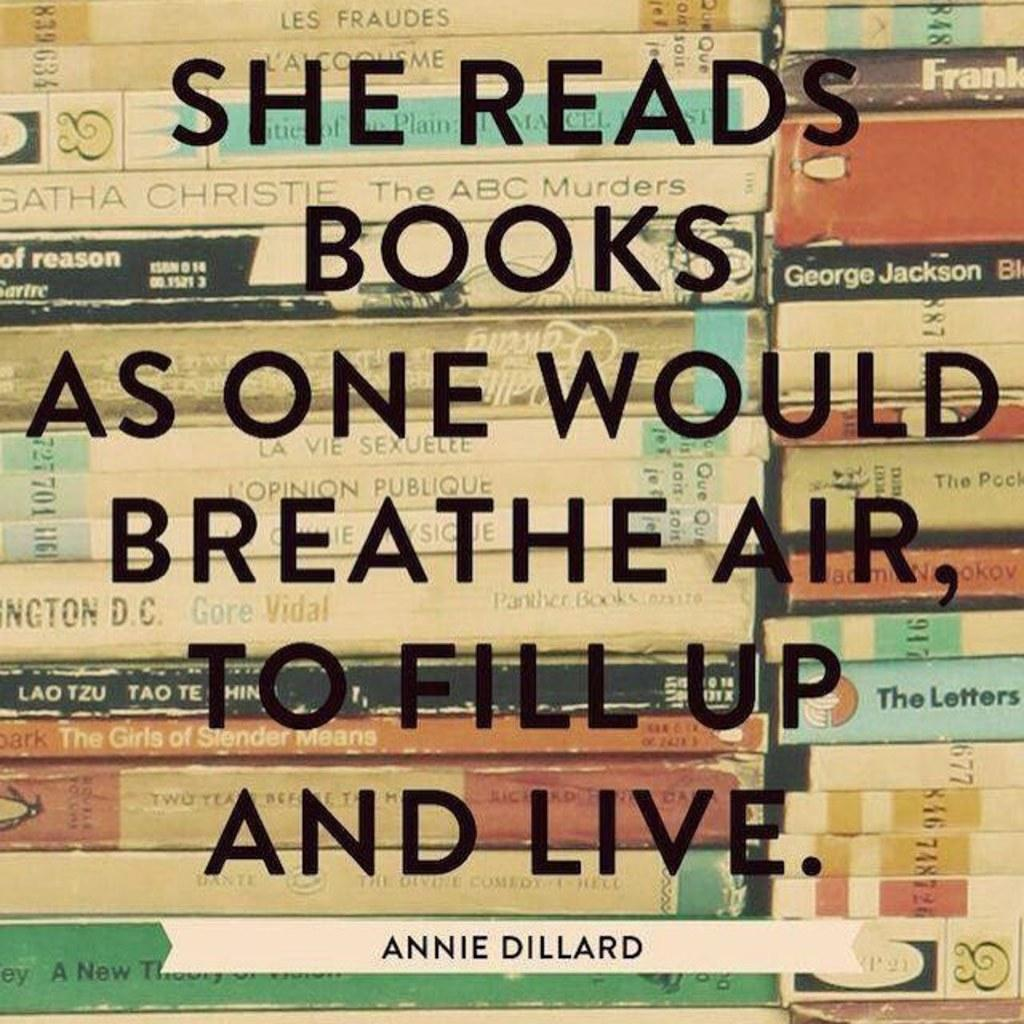Provide a one-sentence caption for the provided image. Sign that says reads books as one would breathe air to fill up and live in front of books. 